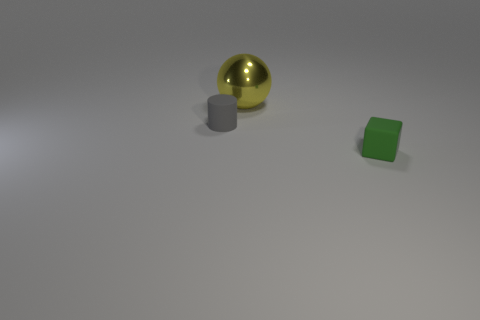There is a object that is the same size as the gray cylinder; what color is it?
Make the answer very short. Green. There is a tiny cube; is its color the same as the tiny rubber object to the left of the sphere?
Provide a short and direct response. No. What is the material of the small thing that is on the right side of the tiny matte object that is left of the green rubber cube?
Your answer should be very brief. Rubber. How many things are both in front of the big yellow thing and on the left side of the matte block?
Make the answer very short. 1. What number of other things are the same size as the yellow thing?
Offer a terse response. 0. Does the small object that is to the left of the shiny thing have the same shape as the small thing in front of the small gray rubber thing?
Keep it short and to the point. No. There is a tiny rubber cylinder; are there any big yellow metal balls behind it?
Give a very brief answer. Yes. Is there anything else that is the same shape as the big object?
Your response must be concise. No. What is the material of the tiny block that is in front of the yellow object?
Your answer should be compact. Rubber. How many green blocks have the same material as the cylinder?
Your answer should be compact. 1. 